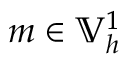<formula> <loc_0><loc_0><loc_500><loc_500>m \in \mathbb { V } _ { h } ^ { 1 }</formula> 